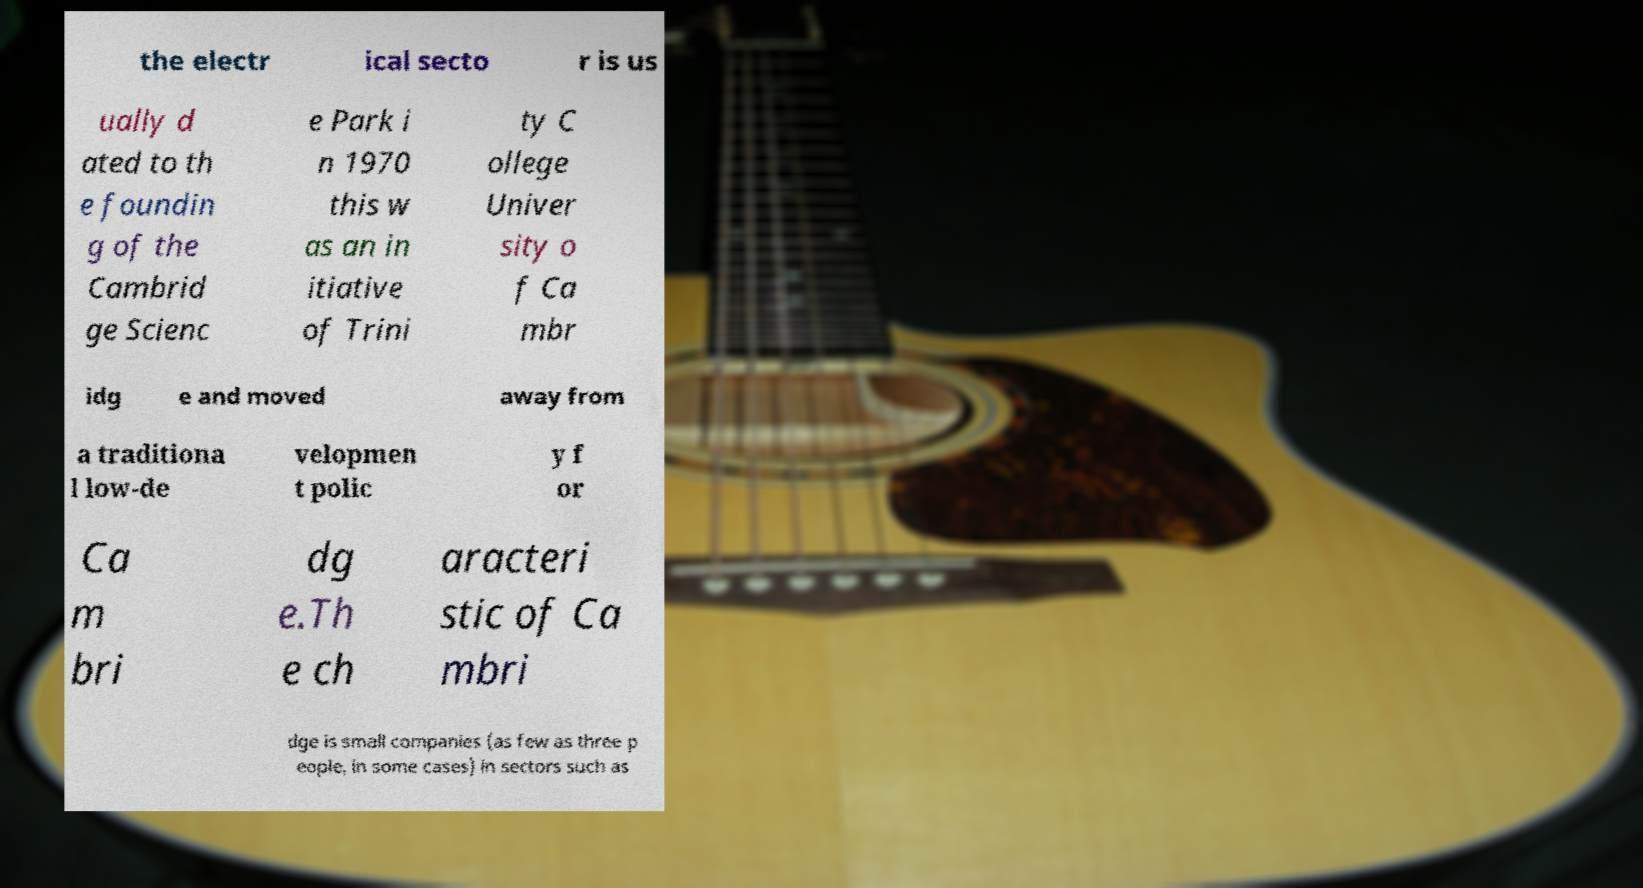Could you assist in decoding the text presented in this image and type it out clearly? the electr ical secto r is us ually d ated to th e foundin g of the Cambrid ge Scienc e Park i n 1970 this w as an in itiative of Trini ty C ollege Univer sity o f Ca mbr idg e and moved away from a traditiona l low-de velopmen t polic y f or Ca m bri dg e.Th e ch aracteri stic of Ca mbri dge is small companies (as few as three p eople, in some cases) in sectors such as 